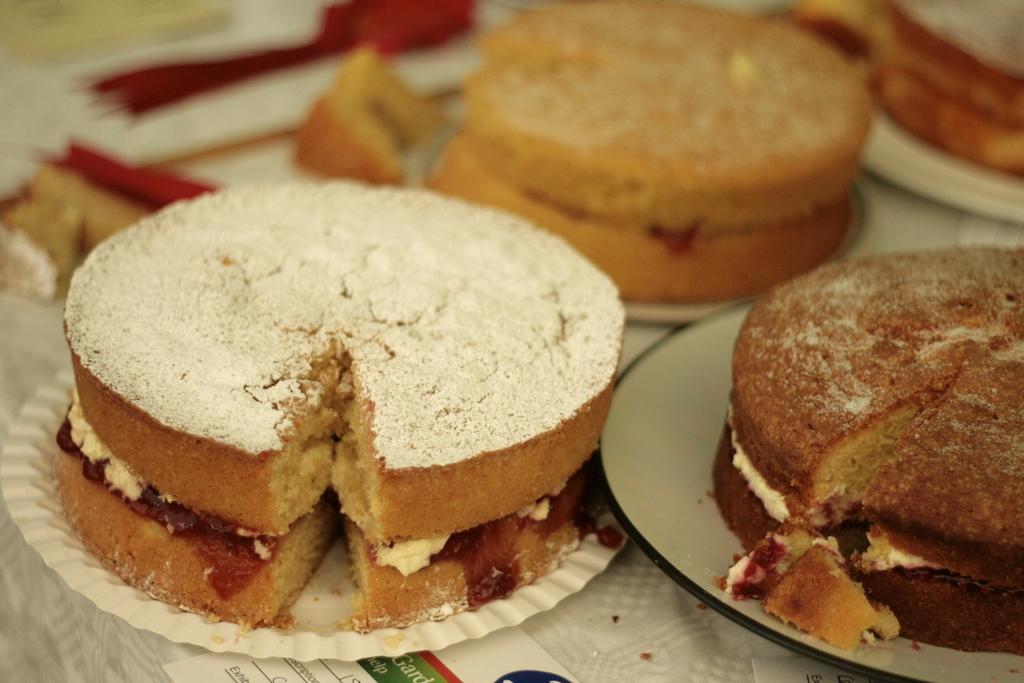Please provide a concise description of this image. In this image there are breads kept on the plates which are kept on the table. The table is covered with a cloth. There are few objects on the table. Bottom of the image there is a paper having some text. 